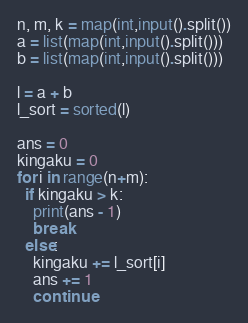Convert code to text. <code><loc_0><loc_0><loc_500><loc_500><_Python_>n, m, k = map(int,input().split())
a = list(map(int,input().split()))
b = list(map(int,input().split()))

l = a + b
l_sort = sorted(l)

ans = 0
kingaku = 0
for i in range(n+m):
  if kingaku > k:
    print(ans - 1)
    break
  else:
    kingaku += l_sort[i]
    ans += 1
    continue
</code> 